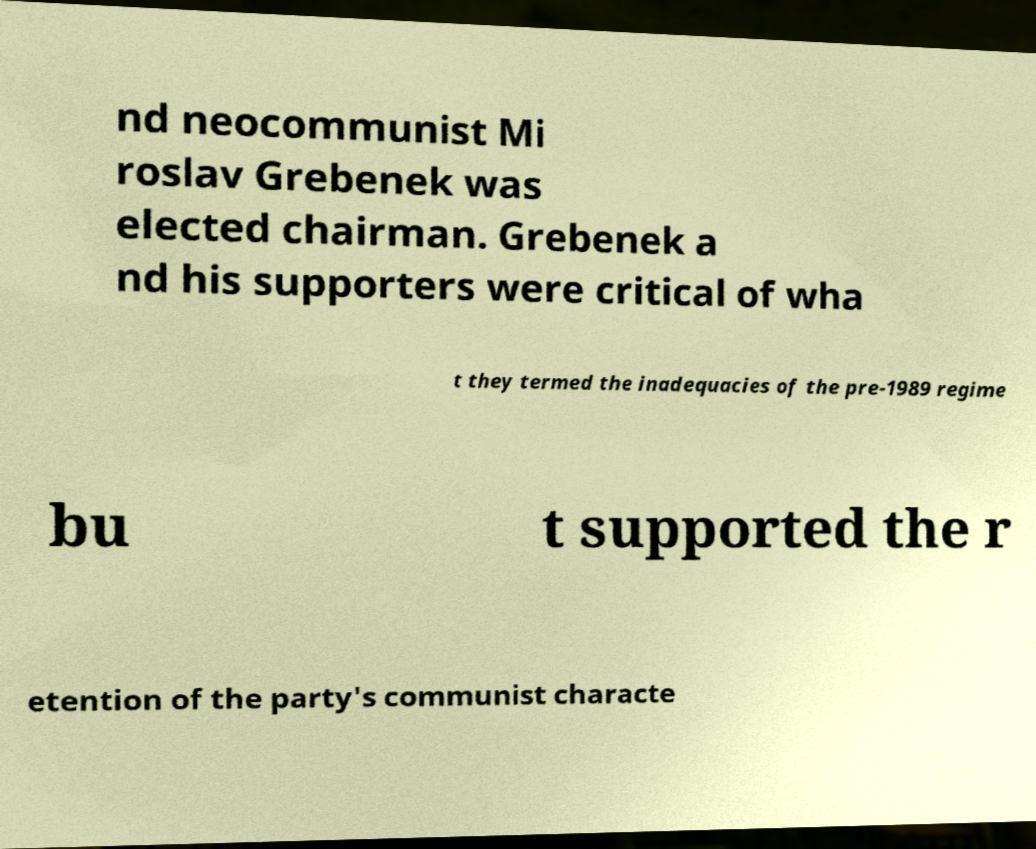Can you accurately transcribe the text from the provided image for me? nd neocommunist Mi roslav Grebenek was elected chairman. Grebenek a nd his supporters were critical of wha t they termed the inadequacies of the pre-1989 regime bu t supported the r etention of the party's communist characte 